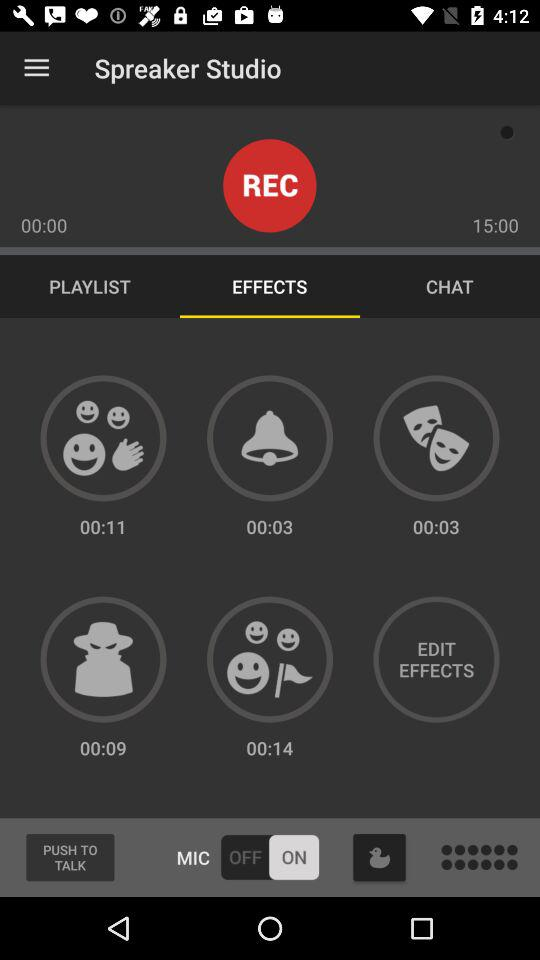What's the status of "MIC"? The status is "on". 